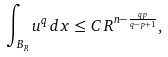<formula> <loc_0><loc_0><loc_500><loc_500>\int _ { B _ { R } } u ^ { q } \, d x \leq C \, R ^ { n - \frac { q p } { q - p + 1 } } ,</formula> 